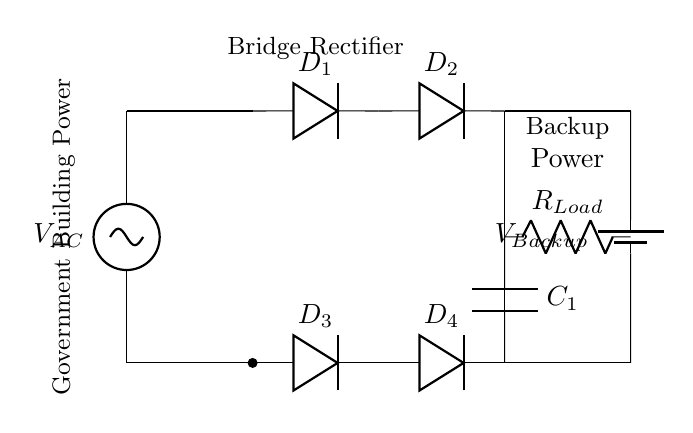What type of rectifier is shown in the diagram? The diagram clearly depicts a bridge rectifier circuit, which is composed of four diodes connected in such a way to convert alternating current (AC) into direct current (DC).
Answer: Bridge rectifier How many diodes are used in this circuit? The circuit diagram shows four diodes labeled as D1, D2, D3, and D4, indicating that a total of four diodes are utilized in the bridge rectifier setup.
Answer: Four diodes What is the role of the capacitor in this circuit? The capacitor, labeled C1 in the circuit, functions to smooth the output voltage after rectification, reducing voltage fluctuations from the rectifier to provide a steadier DC voltage for the load.
Answer: Smoothing Which component provides backup power? The battery labeled as V_Backup in the circuit supplies backup power, ensuring the load receives electricity even if the AC source fails.
Answer: Battery What is the purpose of the load resistor in this circuit? The load resistor, labeled R_Load, represents the component that consumes the electrical power provided by the rectifier and backup system, utilizing the DC voltage for its operation.
Answer: Power consumption How does this circuit ensure uninterrupted power supply? The combination of the bridge rectifier and the backup battery allows the circuit to continue supplying power by converting AC to DC while also providing a stored energy source in case of failure in the AC line, ensuring uninterrupted operation.
Answer: Uninterrupted power What does the AC source provide to the circuit? The AC source, labeled as V_AC, provides the alternating current necessary for the initial power conversion through the bridge rectifier, allowing the diodes to change the AC into usable DC.
Answer: Alternating current 